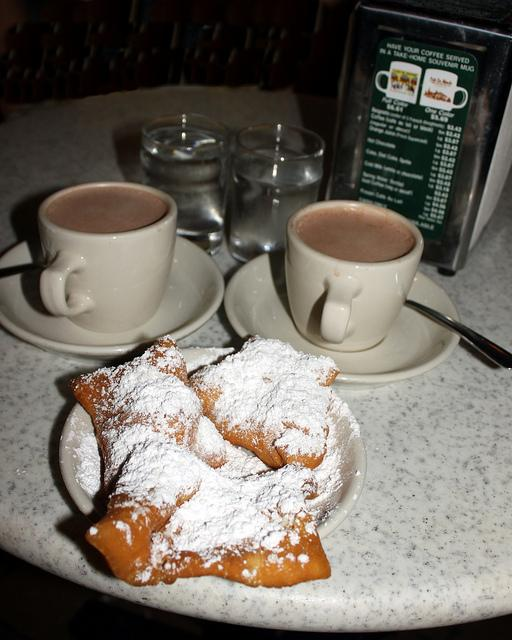What is in the tin box?

Choices:
A) salt
B) pepper
C) sugar
D) napkins napkins 